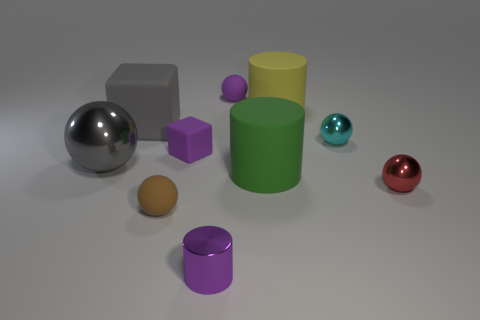Subtract all large gray balls. How many balls are left? 4 Subtract all brown balls. How many balls are left? 4 Subtract all blue spheres. Subtract all purple cylinders. How many spheres are left? 5 Subtract all cylinders. How many objects are left? 7 Subtract all gray metallic objects. Subtract all green rubber cylinders. How many objects are left? 8 Add 4 green matte cylinders. How many green matte cylinders are left? 5 Add 8 small green rubber cylinders. How many small green rubber cylinders exist? 8 Subtract 1 purple cubes. How many objects are left? 9 